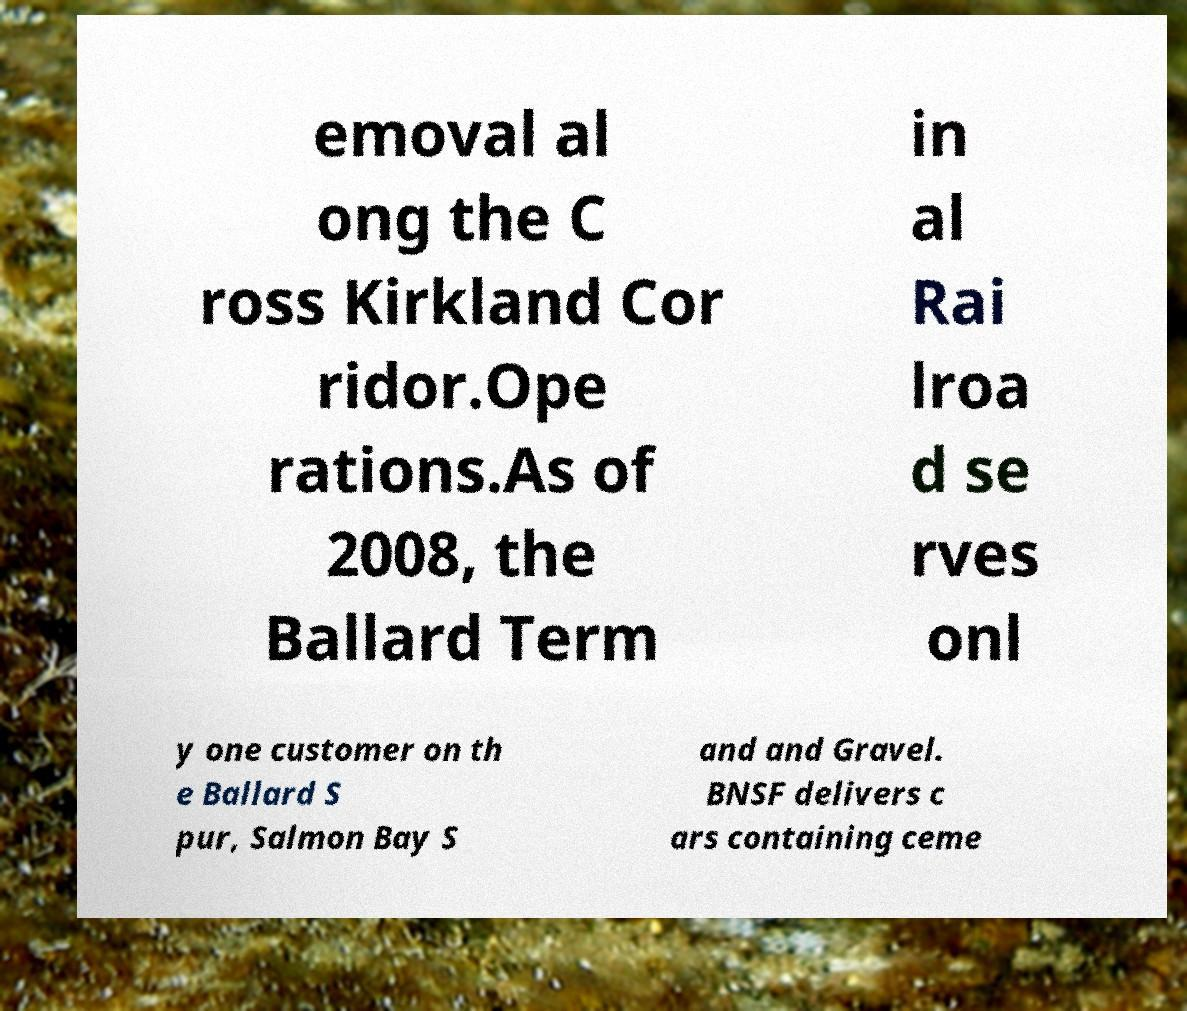Please read and relay the text visible in this image. What does it say? emoval al ong the C ross Kirkland Cor ridor.Ope rations.As of 2008, the Ballard Term in al Rai lroa d se rves onl y one customer on th e Ballard S pur, Salmon Bay S and and Gravel. BNSF delivers c ars containing ceme 